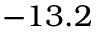<formula> <loc_0><loc_0><loc_500><loc_500>- 1 3 . 2</formula> 